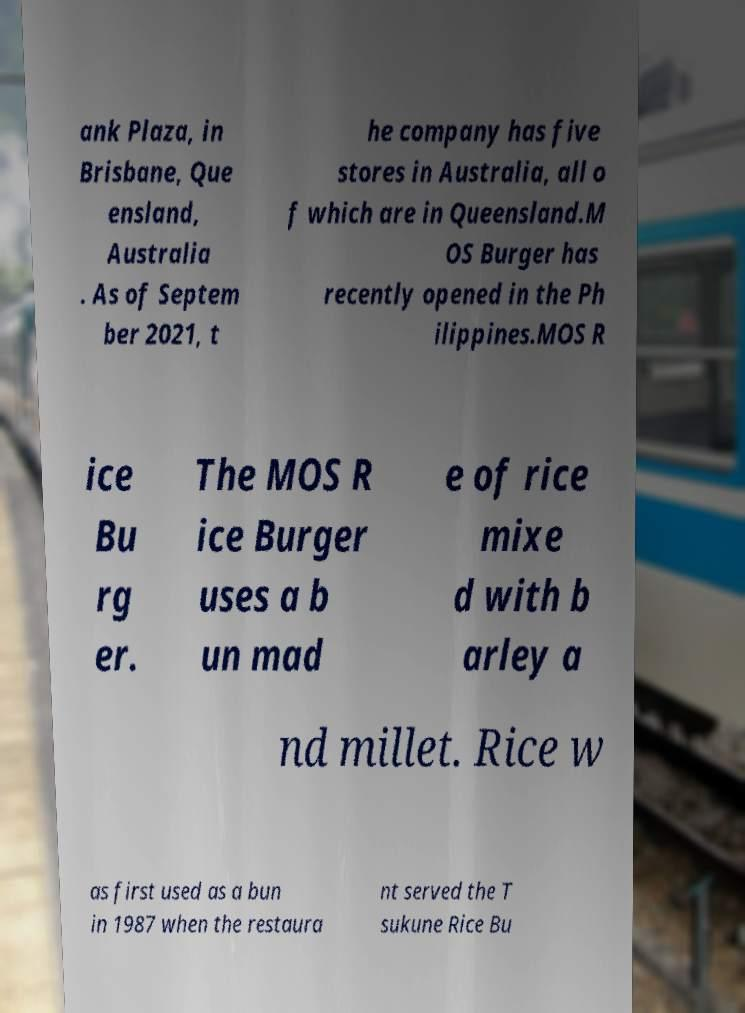Please identify and transcribe the text found in this image. ank Plaza, in Brisbane, Que ensland, Australia . As of Septem ber 2021, t he company has five stores in Australia, all o f which are in Queensland.M OS Burger has recently opened in the Ph ilippines.MOS R ice Bu rg er. The MOS R ice Burger uses a b un mad e of rice mixe d with b arley a nd millet. Rice w as first used as a bun in 1987 when the restaura nt served the T sukune Rice Bu 